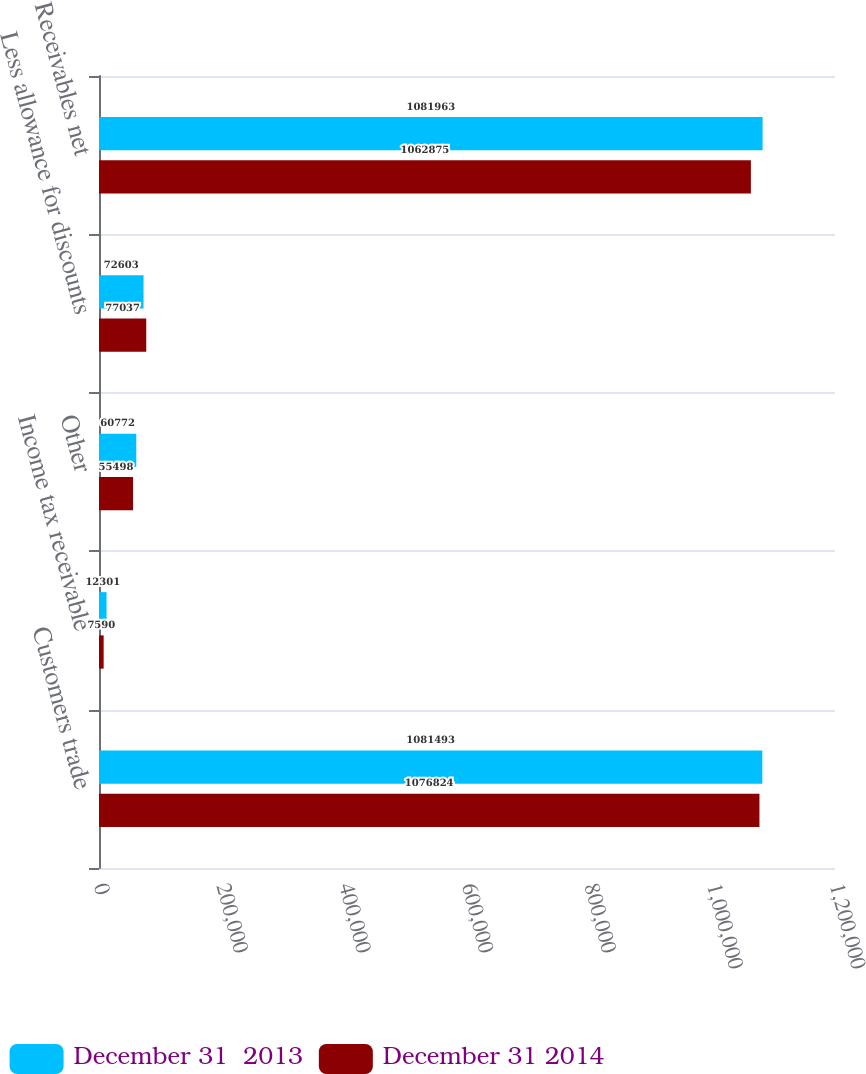Convert chart to OTSL. <chart><loc_0><loc_0><loc_500><loc_500><stacked_bar_chart><ecel><fcel>Customers trade<fcel>Income tax receivable<fcel>Other<fcel>Less allowance for discounts<fcel>Receivables net<nl><fcel>December 31  2013<fcel>1.08149e+06<fcel>12301<fcel>60772<fcel>72603<fcel>1.08196e+06<nl><fcel>December 31 2014<fcel>1.07682e+06<fcel>7590<fcel>55498<fcel>77037<fcel>1.06288e+06<nl></chart> 